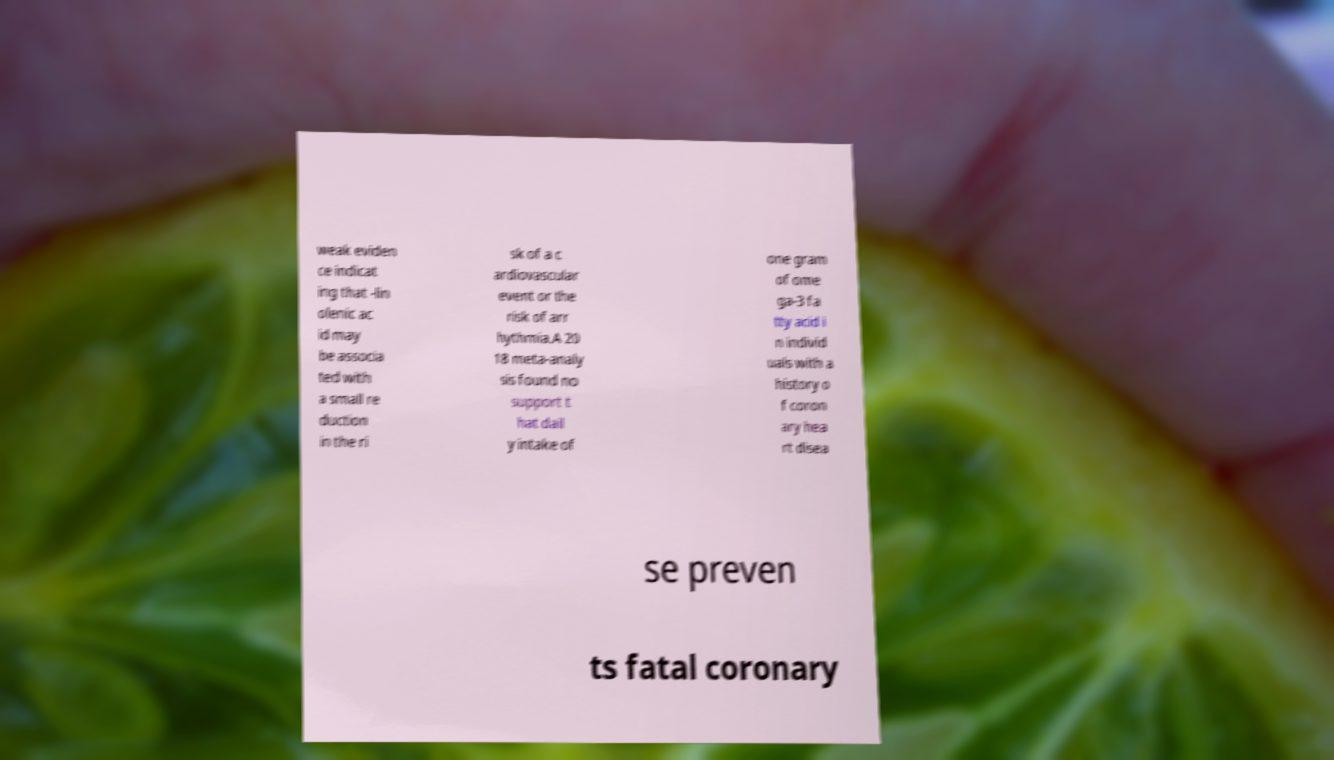For documentation purposes, I need the text within this image transcribed. Could you provide that? weak eviden ce indicat ing that -lin olenic ac id may be associa ted with a small re duction in the ri sk of a c ardiovascular event or the risk of arr hythmia.A 20 18 meta-analy sis found no support t hat dail y intake of one gram of ome ga-3 fa tty acid i n individ uals with a history o f coron ary hea rt disea se preven ts fatal coronary 